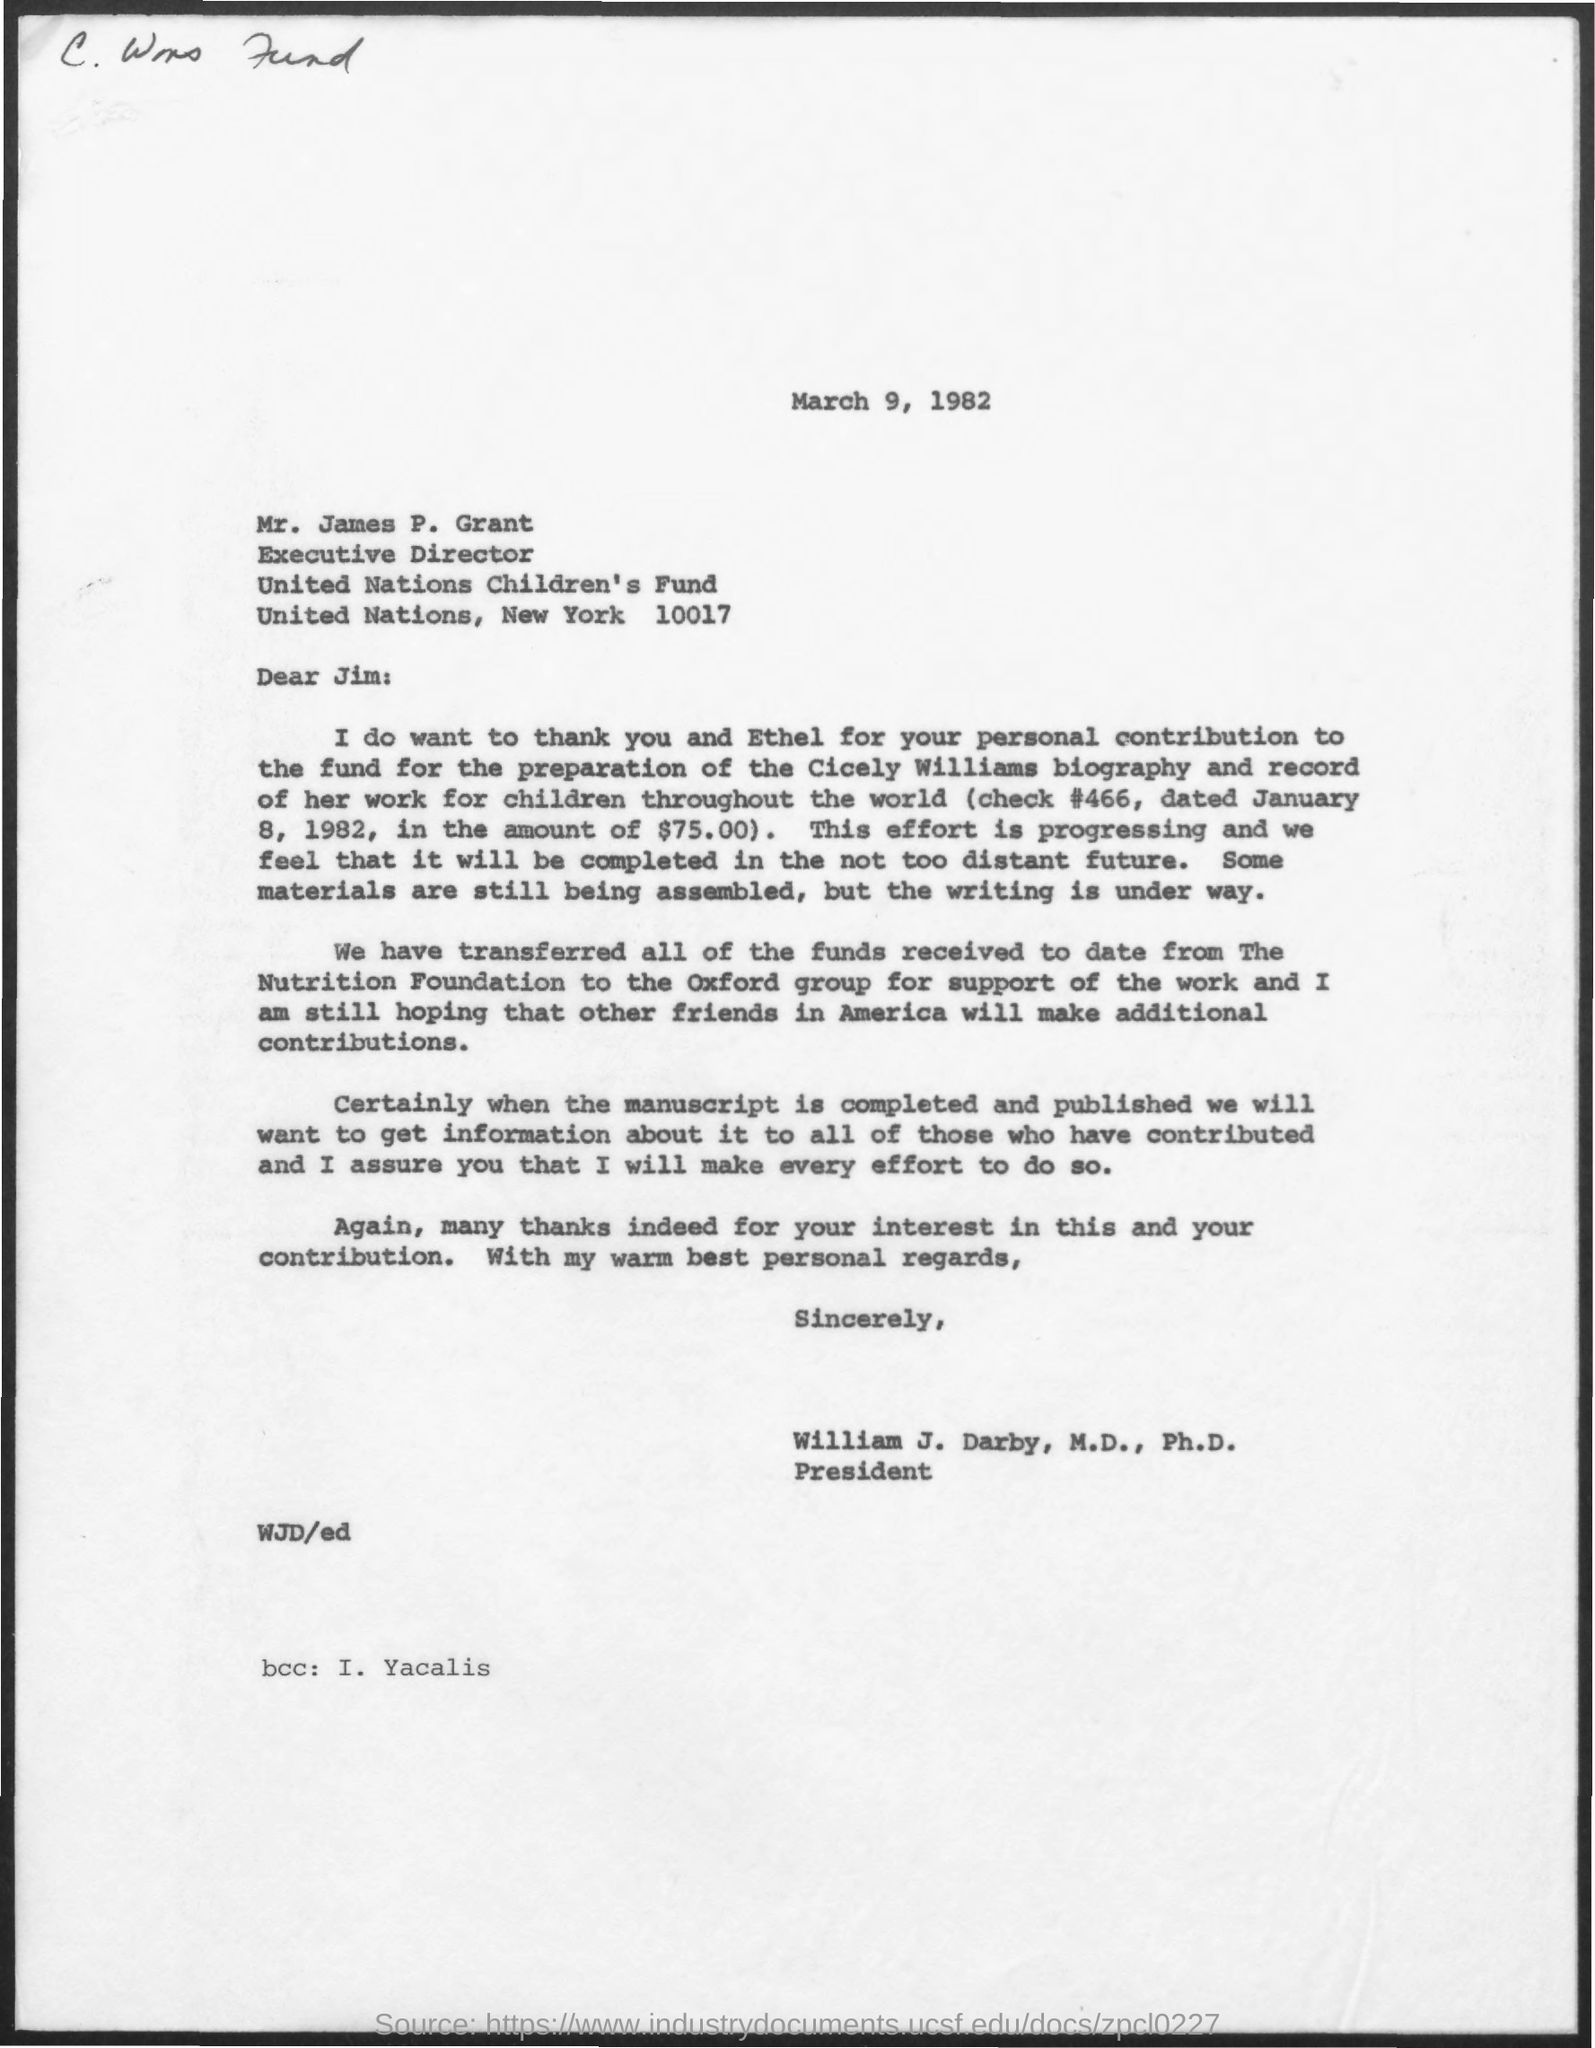Who is the executive director of united nations children's fund?
Your response must be concise. Mr.James P.Grant. In which place the United nations children's fund is located?
Ensure brevity in your answer.  New York. 